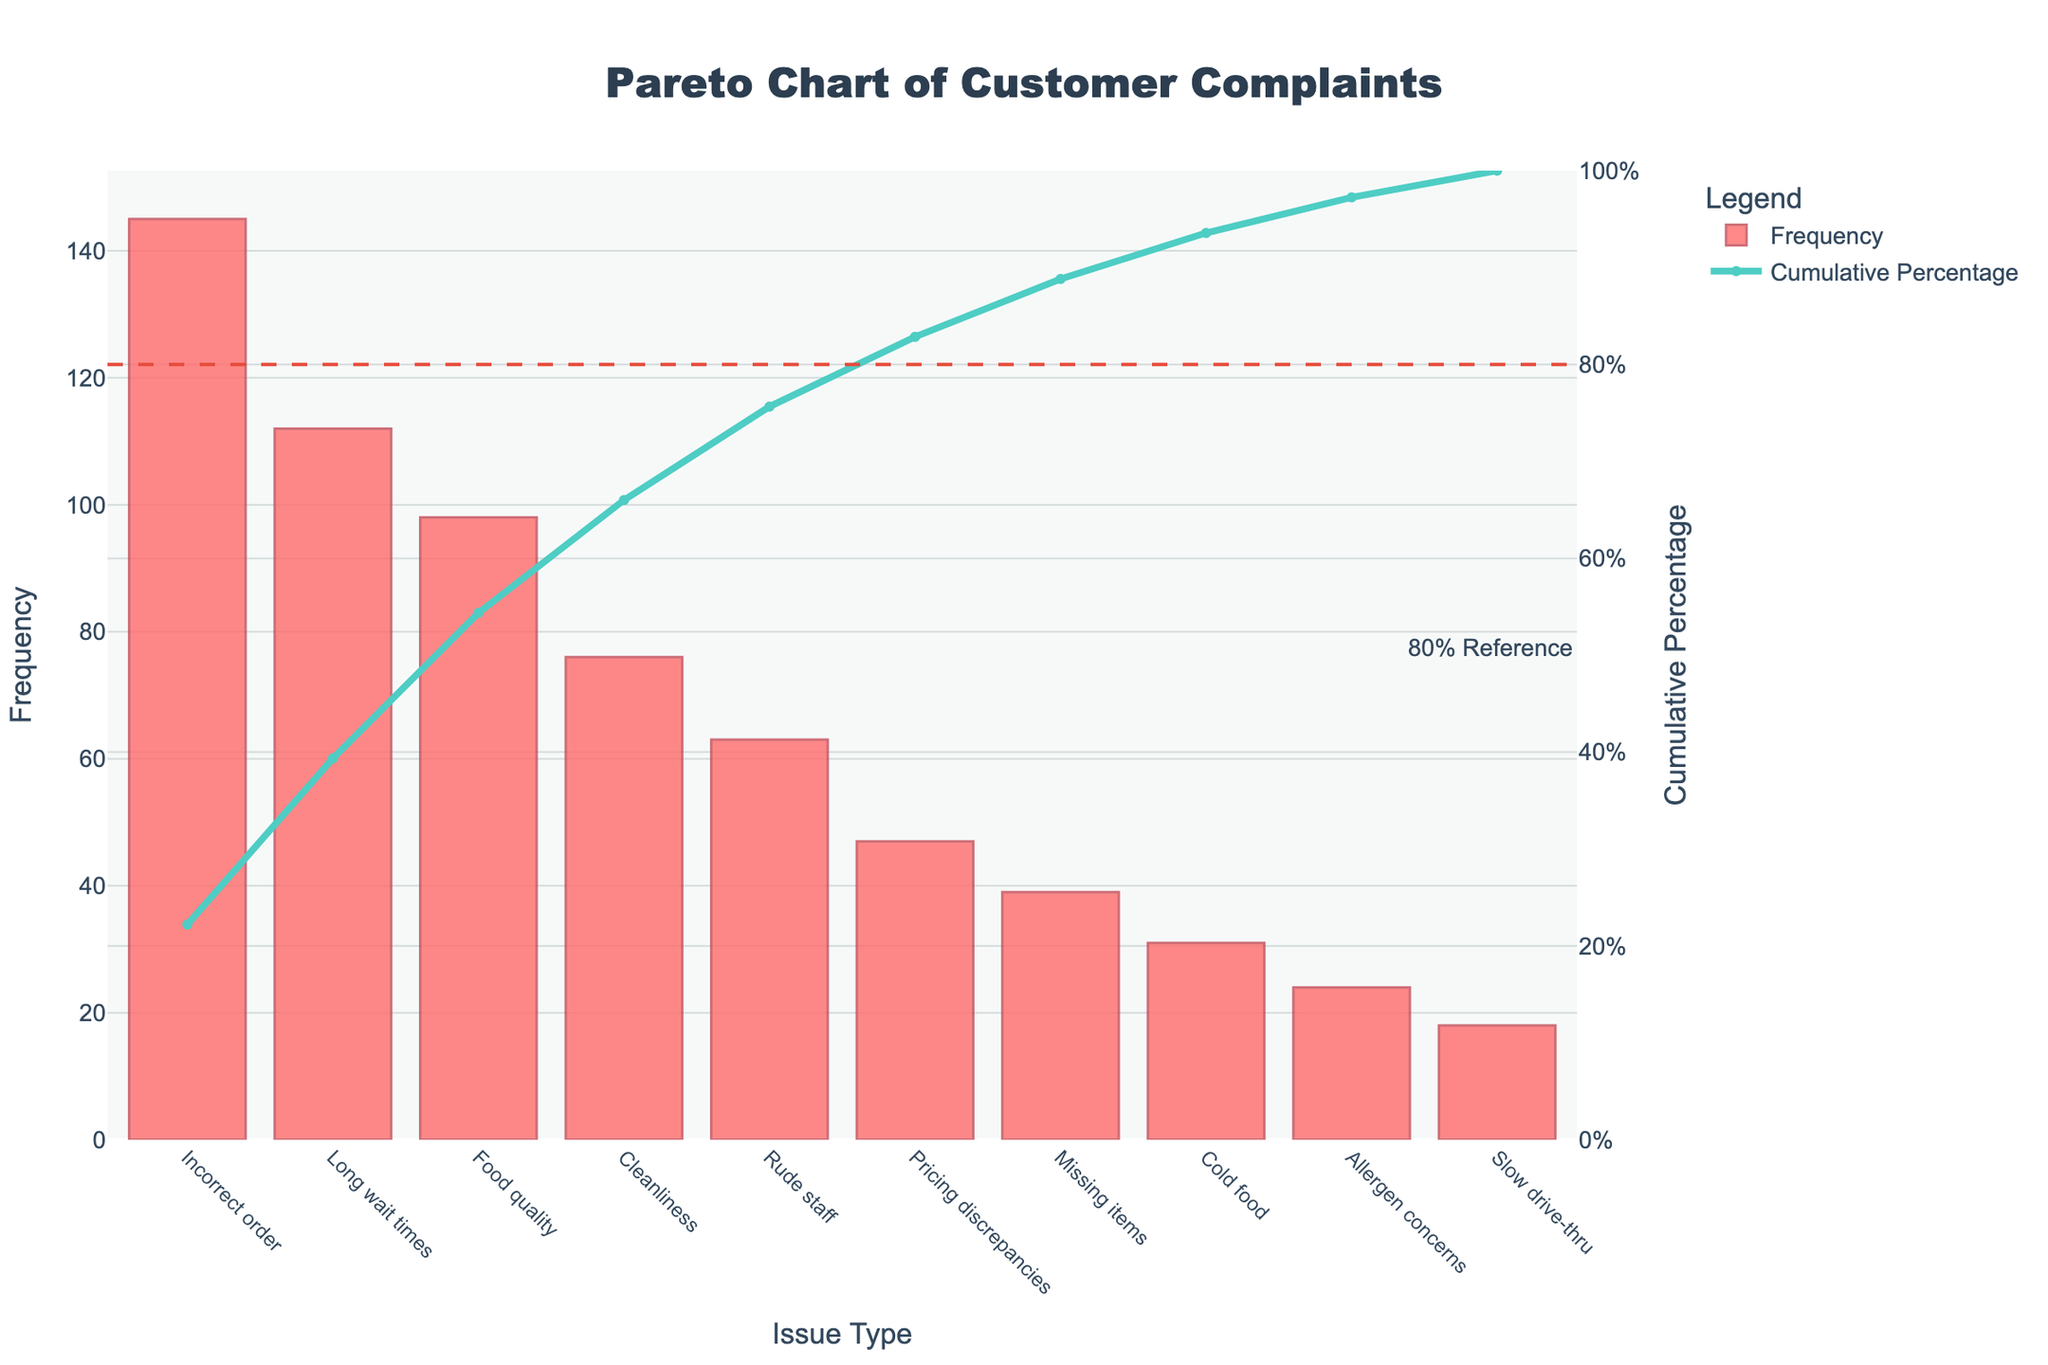What is the title of the chart? The title is typically located at the top of the chart and is used to describe the main topic of the visualization. In this chart, the title clearly states the subject of the Pareto Analysis being displayed.
Answer: Pareto Chart of Customer Complaints Which issue has the highest frequency of complaints? The highest frequency is shown by the tallest bar on the chart. The label on the x-axis corresponding to this bar indicates the issue.
Answer: Incorrect order What does the cumulative percentage line indicate? The cumulative percentage line shows the running total of frequencies, converted into a percentage, moving across the issues from left to right. It helps identify the proportion of total complaints attributed to each issue and to the combination of all preceding issues.
Answer: It indicates the cumulative percentage of total complaints What is the cumulative percentage after the first three most common complaints? To determine this, sum the frequencies of the first three bars and divide by the total of all complaints, then convert to a percentage. The value is also represented by the cumulative percentage line at the third data point.
Answer: Approximately 61.97% By what percentage do 'Incorrect order' and 'Long wait times' combined contribute to total complaints? Sum the frequencies of 'Incorrect order' and 'Long wait times' and divide by the total frequency of all complaints. Convert this to a percentage. This value is also shown on the cumulative percentage line after the second bar.
Answer: Approximately 47.28% Which issue is the 80% reference line closest to in terms of cumulative percentage? The 80% reference line is a horizontal line placed on the cumulative percentage axis. The issue that the cumulative percentage line reaches this reference line is the one being asked for.
Answer: Rude staff How many different issues are presented in the chart? Count the number of distinct bars or labels on the x-axis of the chart.
Answer: 10 What is the percentage contributed by the 'Rude staff' issue alone to the total complaints? The frequency of 'Rude staff' divided by the total frequency of all complaints, then converted to a percentage.
Answer: Approximately 8.33% Which issue has fewer complaints: 'Cold food' or 'Slow drive-thru'? Compare the heights of the bars corresponding to 'Cold food' and 'Slow drive-thru' issues. The shorter bar indicates fewer complaints.
Answer: Slow drive-thru If you had to address the top 80% of the issues, how many unique issues would you need to address? Identify the cumulative percentage value point at or just before the 80% mark. Count the number of issues up to this point in the chart.
Answer: 5 